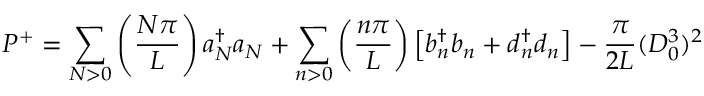<formula> <loc_0><loc_0><loc_500><loc_500>P ^ { + } = \sum _ { N > 0 } \left ( { \frac { N \pi } { L } } \right ) a { _ { N } ^ { \dagger } } a _ { N } + \sum _ { n > 0 } \left ( { \frac { n \pi } { L } } \right ) \left [ b { _ { n } ^ { \dagger } } b _ { n } + d { _ { n } ^ { \dagger } } d _ { n } \right ] - { \frac { \pi } { 2 L } } ( D _ { 0 } ^ { 3 } ) ^ { 2 }</formula> 